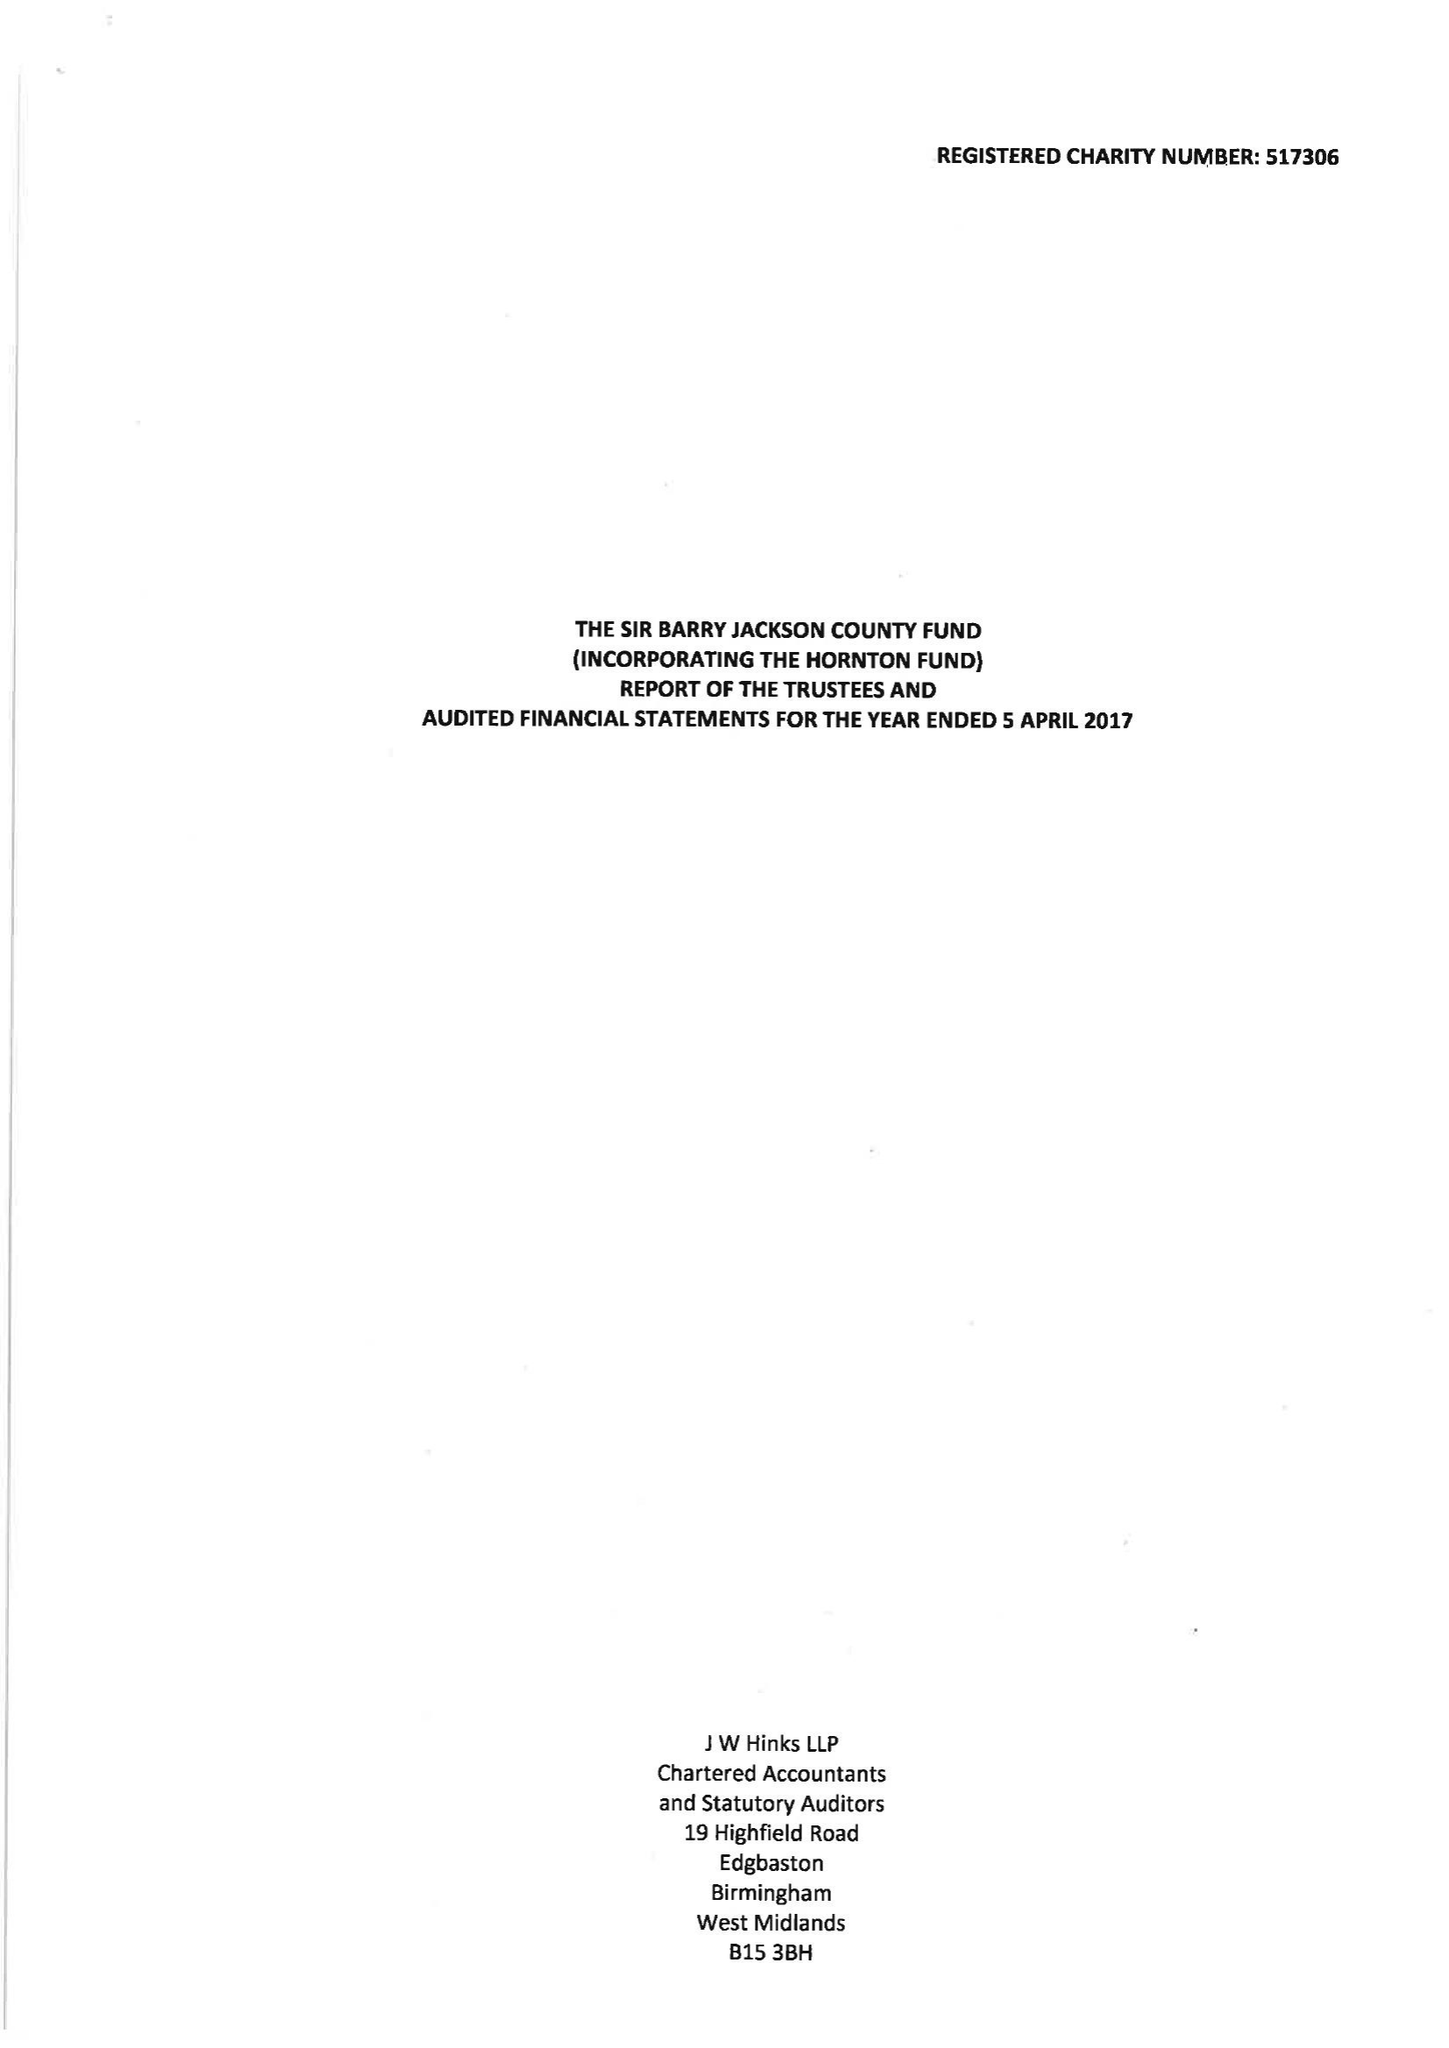What is the value for the income_annually_in_british_pounds?
Answer the question using a single word or phrase. 97976.00 